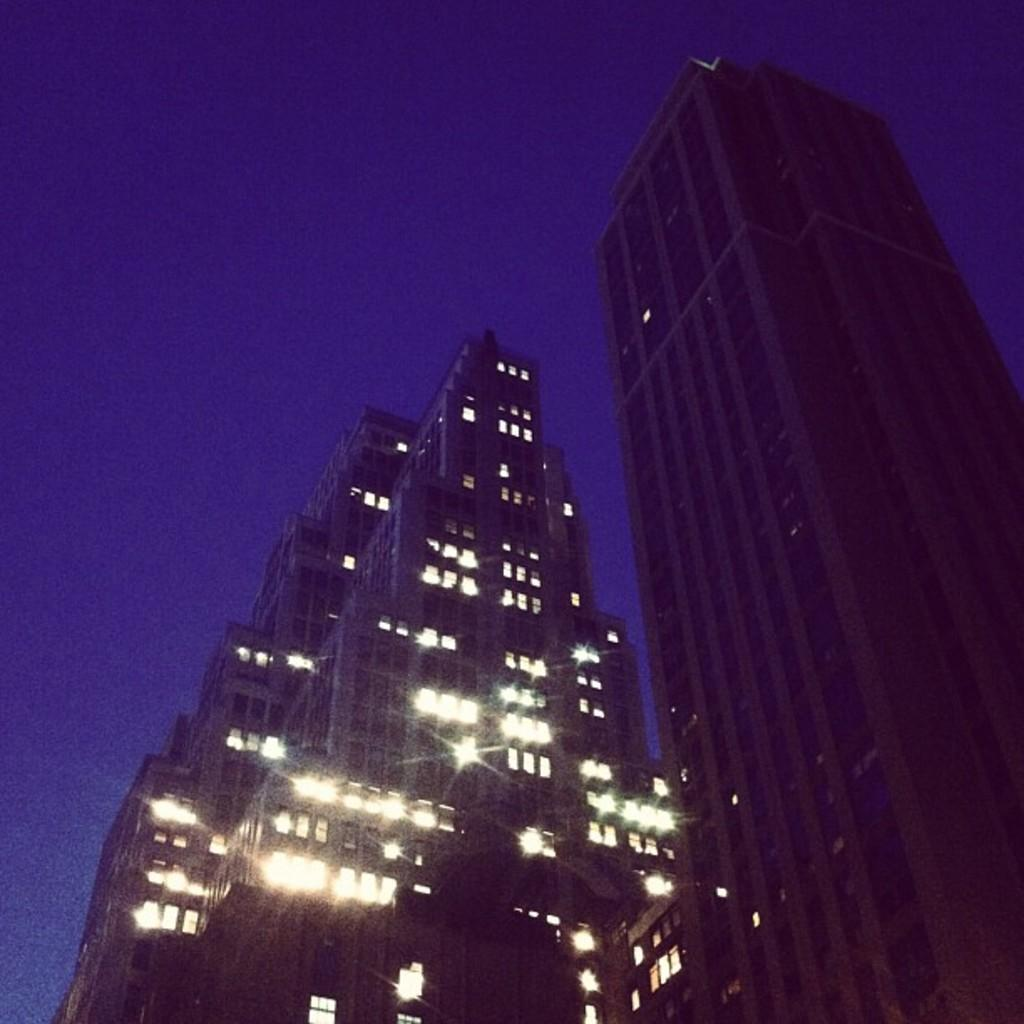What type of structures can be seen in the image? There are buildings in the image. What else is visible in the image besides the buildings? Lights are present in the image. What is the condition of the sky in the image? The sky is clear in the image. What type of interest does the mountain in the image represent? There is no mountain present in the image, so it cannot represent any interest. 